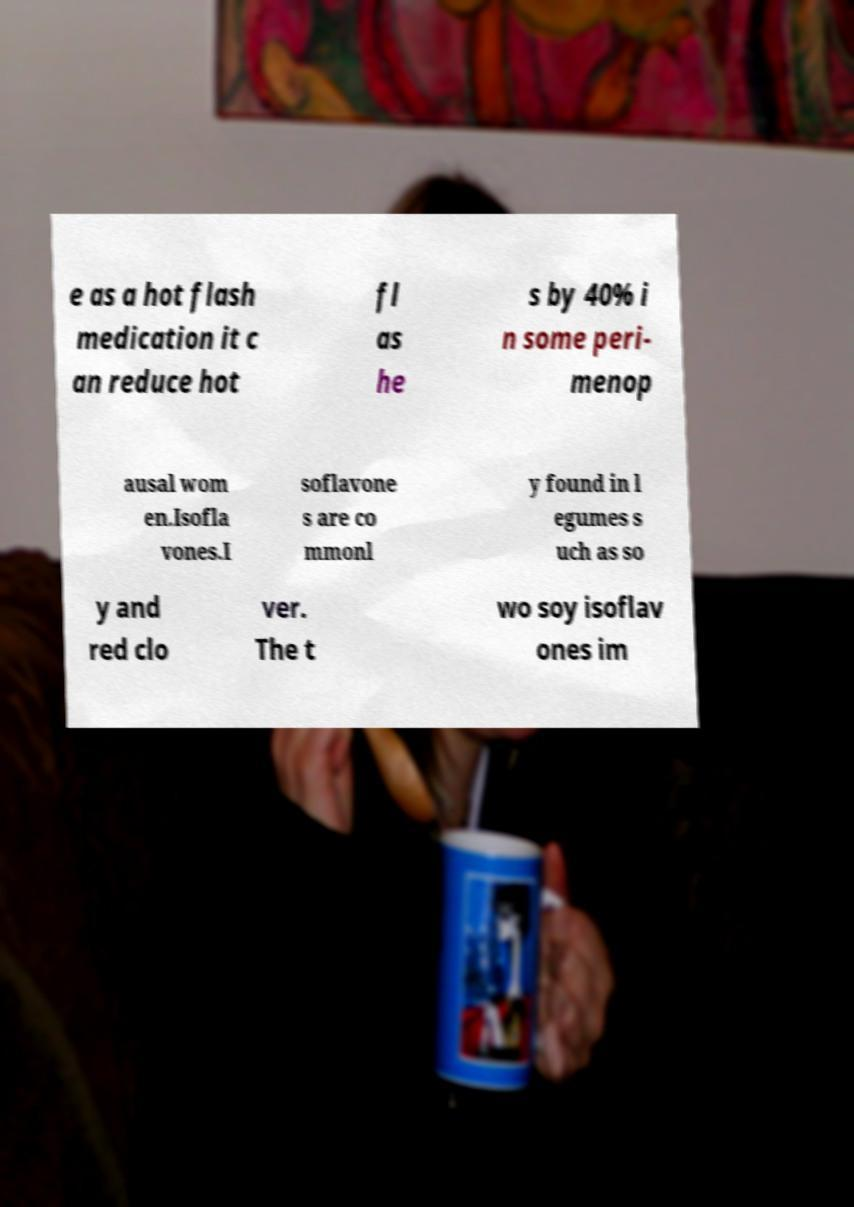I need the written content from this picture converted into text. Can you do that? e as a hot flash medication it c an reduce hot fl as he s by 40% i n some peri- menop ausal wom en.Isofla vones.I soflavone s are co mmonl y found in l egumes s uch as so y and red clo ver. The t wo soy isoflav ones im 